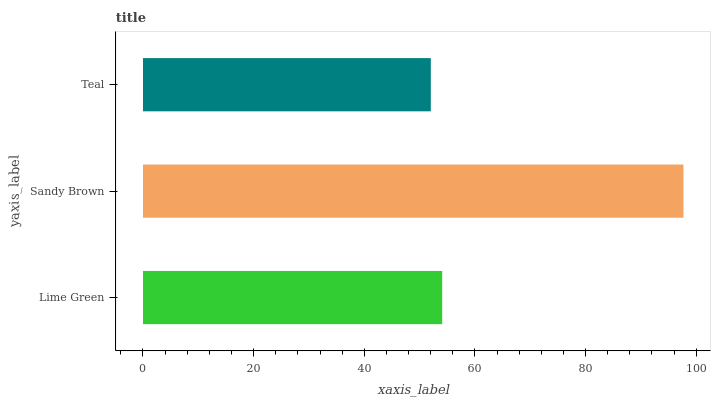Is Teal the minimum?
Answer yes or no. Yes. Is Sandy Brown the maximum?
Answer yes or no. Yes. Is Sandy Brown the minimum?
Answer yes or no. No. Is Teal the maximum?
Answer yes or no. No. Is Sandy Brown greater than Teal?
Answer yes or no. Yes. Is Teal less than Sandy Brown?
Answer yes or no. Yes. Is Teal greater than Sandy Brown?
Answer yes or no. No. Is Sandy Brown less than Teal?
Answer yes or no. No. Is Lime Green the high median?
Answer yes or no. Yes. Is Lime Green the low median?
Answer yes or no. Yes. Is Teal the high median?
Answer yes or no. No. Is Teal the low median?
Answer yes or no. No. 